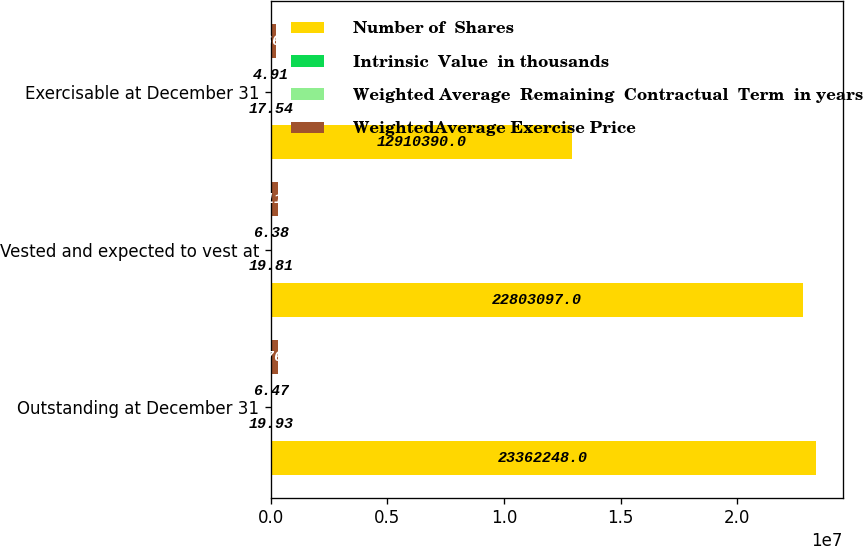<chart> <loc_0><loc_0><loc_500><loc_500><stacked_bar_chart><ecel><fcel>Outstanding at December 31<fcel>Vested and expected to vest at<fcel>Exercisable at December 31<nl><fcel>Number of  Shares<fcel>2.33622e+07<fcel>2.28031e+07<fcel>1.29104e+07<nl><fcel>Intrinsic  Value  in thousands<fcel>19.93<fcel>19.81<fcel>17.54<nl><fcel>Weighted Average  Remaining  Contractual  Term  in years<fcel>6.47<fcel>6.38<fcel>4.91<nl><fcel>WeightedAverage Exercise Price<fcel>308766<fcel>304116<fcel>201662<nl></chart> 